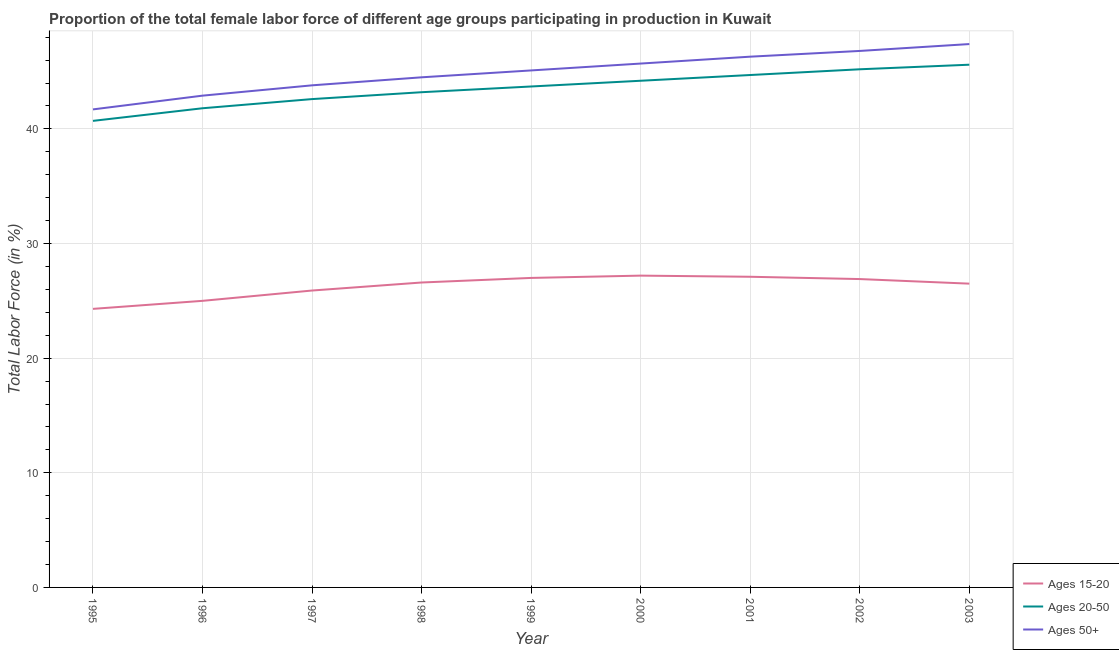How many different coloured lines are there?
Keep it short and to the point. 3. Does the line corresponding to percentage of female labor force within the age group 20-50 intersect with the line corresponding to percentage of female labor force above age 50?
Your answer should be very brief. No. What is the percentage of female labor force within the age group 20-50 in 1998?
Make the answer very short. 43.2. Across all years, what is the maximum percentage of female labor force within the age group 15-20?
Make the answer very short. 27.2. Across all years, what is the minimum percentage of female labor force within the age group 20-50?
Provide a succinct answer. 40.7. In which year was the percentage of female labor force above age 50 minimum?
Keep it short and to the point. 1995. What is the total percentage of female labor force within the age group 15-20 in the graph?
Give a very brief answer. 236.5. What is the difference between the percentage of female labor force above age 50 in 2002 and that in 2003?
Make the answer very short. -0.6. What is the difference between the percentage of female labor force above age 50 in 1997 and the percentage of female labor force within the age group 20-50 in 2001?
Your answer should be very brief. -0.9. What is the average percentage of female labor force above age 50 per year?
Provide a short and direct response. 44.91. In how many years, is the percentage of female labor force above age 50 greater than 10 %?
Offer a terse response. 9. What is the ratio of the percentage of female labor force within the age group 20-50 in 2000 to that in 2001?
Ensure brevity in your answer.  0.99. Is the percentage of female labor force within the age group 15-20 in 1998 less than that in 1999?
Keep it short and to the point. Yes. What is the difference between the highest and the second highest percentage of female labor force above age 50?
Your answer should be very brief. 0.6. What is the difference between the highest and the lowest percentage of female labor force within the age group 20-50?
Keep it short and to the point. 4.9. Is the sum of the percentage of female labor force within the age group 20-50 in 1999 and 2001 greater than the maximum percentage of female labor force within the age group 15-20 across all years?
Your answer should be compact. Yes. Is it the case that in every year, the sum of the percentage of female labor force within the age group 15-20 and percentage of female labor force within the age group 20-50 is greater than the percentage of female labor force above age 50?
Give a very brief answer. Yes. Are the values on the major ticks of Y-axis written in scientific E-notation?
Your response must be concise. No. Does the graph contain any zero values?
Your response must be concise. No. What is the title of the graph?
Provide a short and direct response. Proportion of the total female labor force of different age groups participating in production in Kuwait. Does "Non-communicable diseases" appear as one of the legend labels in the graph?
Your answer should be very brief. No. What is the Total Labor Force (in %) in Ages 15-20 in 1995?
Your answer should be compact. 24.3. What is the Total Labor Force (in %) in Ages 20-50 in 1995?
Provide a succinct answer. 40.7. What is the Total Labor Force (in %) of Ages 50+ in 1995?
Give a very brief answer. 41.7. What is the Total Labor Force (in %) of Ages 20-50 in 1996?
Your response must be concise. 41.8. What is the Total Labor Force (in %) in Ages 50+ in 1996?
Your answer should be compact. 42.9. What is the Total Labor Force (in %) of Ages 15-20 in 1997?
Give a very brief answer. 25.9. What is the Total Labor Force (in %) in Ages 20-50 in 1997?
Your answer should be compact. 42.6. What is the Total Labor Force (in %) in Ages 50+ in 1997?
Make the answer very short. 43.8. What is the Total Labor Force (in %) in Ages 15-20 in 1998?
Give a very brief answer. 26.6. What is the Total Labor Force (in %) in Ages 20-50 in 1998?
Offer a very short reply. 43.2. What is the Total Labor Force (in %) in Ages 50+ in 1998?
Your response must be concise. 44.5. What is the Total Labor Force (in %) of Ages 20-50 in 1999?
Give a very brief answer. 43.7. What is the Total Labor Force (in %) of Ages 50+ in 1999?
Provide a succinct answer. 45.1. What is the Total Labor Force (in %) in Ages 15-20 in 2000?
Offer a very short reply. 27.2. What is the Total Labor Force (in %) of Ages 20-50 in 2000?
Your answer should be compact. 44.2. What is the Total Labor Force (in %) in Ages 50+ in 2000?
Provide a short and direct response. 45.7. What is the Total Labor Force (in %) of Ages 15-20 in 2001?
Your response must be concise. 27.1. What is the Total Labor Force (in %) in Ages 20-50 in 2001?
Your response must be concise. 44.7. What is the Total Labor Force (in %) in Ages 50+ in 2001?
Your answer should be very brief. 46.3. What is the Total Labor Force (in %) of Ages 15-20 in 2002?
Offer a terse response. 26.9. What is the Total Labor Force (in %) of Ages 20-50 in 2002?
Offer a very short reply. 45.2. What is the Total Labor Force (in %) of Ages 50+ in 2002?
Your answer should be compact. 46.8. What is the Total Labor Force (in %) of Ages 20-50 in 2003?
Your answer should be compact. 45.6. What is the Total Labor Force (in %) in Ages 50+ in 2003?
Make the answer very short. 47.4. Across all years, what is the maximum Total Labor Force (in %) in Ages 15-20?
Keep it short and to the point. 27.2. Across all years, what is the maximum Total Labor Force (in %) of Ages 20-50?
Offer a terse response. 45.6. Across all years, what is the maximum Total Labor Force (in %) in Ages 50+?
Offer a terse response. 47.4. Across all years, what is the minimum Total Labor Force (in %) in Ages 15-20?
Provide a short and direct response. 24.3. Across all years, what is the minimum Total Labor Force (in %) in Ages 20-50?
Make the answer very short. 40.7. Across all years, what is the minimum Total Labor Force (in %) of Ages 50+?
Your answer should be compact. 41.7. What is the total Total Labor Force (in %) in Ages 15-20 in the graph?
Provide a succinct answer. 236.5. What is the total Total Labor Force (in %) of Ages 20-50 in the graph?
Give a very brief answer. 391.7. What is the total Total Labor Force (in %) of Ages 50+ in the graph?
Ensure brevity in your answer.  404.2. What is the difference between the Total Labor Force (in %) of Ages 50+ in 1995 and that in 1996?
Your answer should be very brief. -1.2. What is the difference between the Total Labor Force (in %) in Ages 15-20 in 1995 and that in 1998?
Your answer should be very brief. -2.3. What is the difference between the Total Labor Force (in %) of Ages 50+ in 1995 and that in 1998?
Ensure brevity in your answer.  -2.8. What is the difference between the Total Labor Force (in %) of Ages 20-50 in 1995 and that in 1999?
Provide a succinct answer. -3. What is the difference between the Total Labor Force (in %) of Ages 50+ in 1995 and that in 1999?
Ensure brevity in your answer.  -3.4. What is the difference between the Total Labor Force (in %) of Ages 15-20 in 1995 and that in 2000?
Provide a short and direct response. -2.9. What is the difference between the Total Labor Force (in %) of Ages 50+ in 1995 and that in 2001?
Your answer should be compact. -4.6. What is the difference between the Total Labor Force (in %) in Ages 15-20 in 1995 and that in 2002?
Ensure brevity in your answer.  -2.6. What is the difference between the Total Labor Force (in %) in Ages 20-50 in 1995 and that in 2002?
Offer a very short reply. -4.5. What is the difference between the Total Labor Force (in %) of Ages 50+ in 1995 and that in 2002?
Your answer should be very brief. -5.1. What is the difference between the Total Labor Force (in %) of Ages 15-20 in 1995 and that in 2003?
Your answer should be compact. -2.2. What is the difference between the Total Labor Force (in %) in Ages 15-20 in 1996 and that in 1997?
Your response must be concise. -0.9. What is the difference between the Total Labor Force (in %) in Ages 50+ in 1996 and that in 1997?
Make the answer very short. -0.9. What is the difference between the Total Labor Force (in %) in Ages 15-20 in 1996 and that in 1998?
Your response must be concise. -1.6. What is the difference between the Total Labor Force (in %) in Ages 20-50 in 1996 and that in 1998?
Your answer should be very brief. -1.4. What is the difference between the Total Labor Force (in %) of Ages 50+ in 1996 and that in 1998?
Make the answer very short. -1.6. What is the difference between the Total Labor Force (in %) of Ages 50+ in 1996 and that in 1999?
Your answer should be compact. -2.2. What is the difference between the Total Labor Force (in %) in Ages 15-20 in 1996 and that in 2000?
Make the answer very short. -2.2. What is the difference between the Total Labor Force (in %) of Ages 50+ in 1996 and that in 2000?
Your answer should be compact. -2.8. What is the difference between the Total Labor Force (in %) of Ages 20-50 in 1996 and that in 2001?
Offer a very short reply. -2.9. What is the difference between the Total Labor Force (in %) in Ages 50+ in 1996 and that in 2001?
Offer a terse response. -3.4. What is the difference between the Total Labor Force (in %) of Ages 15-20 in 1996 and that in 2002?
Give a very brief answer. -1.9. What is the difference between the Total Labor Force (in %) of Ages 15-20 in 1996 and that in 2003?
Provide a succinct answer. -1.5. What is the difference between the Total Labor Force (in %) in Ages 20-50 in 1996 and that in 2003?
Ensure brevity in your answer.  -3.8. What is the difference between the Total Labor Force (in %) in Ages 15-20 in 1997 and that in 1998?
Offer a terse response. -0.7. What is the difference between the Total Labor Force (in %) in Ages 20-50 in 1997 and that in 1999?
Make the answer very short. -1.1. What is the difference between the Total Labor Force (in %) in Ages 50+ in 1997 and that in 1999?
Give a very brief answer. -1.3. What is the difference between the Total Labor Force (in %) of Ages 20-50 in 1997 and that in 2000?
Give a very brief answer. -1.6. What is the difference between the Total Labor Force (in %) in Ages 50+ in 1997 and that in 2000?
Keep it short and to the point. -1.9. What is the difference between the Total Labor Force (in %) in Ages 50+ in 1997 and that in 2001?
Your answer should be very brief. -2.5. What is the difference between the Total Labor Force (in %) of Ages 15-20 in 1997 and that in 2002?
Keep it short and to the point. -1. What is the difference between the Total Labor Force (in %) of Ages 20-50 in 1997 and that in 2002?
Offer a very short reply. -2.6. What is the difference between the Total Labor Force (in %) of Ages 50+ in 1997 and that in 2003?
Provide a succinct answer. -3.6. What is the difference between the Total Labor Force (in %) in Ages 15-20 in 1998 and that in 1999?
Give a very brief answer. -0.4. What is the difference between the Total Labor Force (in %) in Ages 15-20 in 1998 and that in 2000?
Give a very brief answer. -0.6. What is the difference between the Total Labor Force (in %) in Ages 20-50 in 1998 and that in 2000?
Ensure brevity in your answer.  -1. What is the difference between the Total Labor Force (in %) in Ages 15-20 in 1998 and that in 2001?
Your response must be concise. -0.5. What is the difference between the Total Labor Force (in %) of Ages 50+ in 1998 and that in 2001?
Your response must be concise. -1.8. What is the difference between the Total Labor Force (in %) of Ages 20-50 in 1998 and that in 2002?
Keep it short and to the point. -2. What is the difference between the Total Labor Force (in %) of Ages 50+ in 1998 and that in 2002?
Offer a very short reply. -2.3. What is the difference between the Total Labor Force (in %) of Ages 50+ in 1999 and that in 2000?
Keep it short and to the point. -0.6. What is the difference between the Total Labor Force (in %) of Ages 15-20 in 1999 and that in 2001?
Ensure brevity in your answer.  -0.1. What is the difference between the Total Labor Force (in %) in Ages 20-50 in 1999 and that in 2001?
Make the answer very short. -1. What is the difference between the Total Labor Force (in %) of Ages 20-50 in 1999 and that in 2002?
Your response must be concise. -1.5. What is the difference between the Total Labor Force (in %) in Ages 50+ in 1999 and that in 2002?
Offer a terse response. -1.7. What is the difference between the Total Labor Force (in %) of Ages 20-50 in 1999 and that in 2003?
Offer a very short reply. -1.9. What is the difference between the Total Labor Force (in %) in Ages 15-20 in 2000 and that in 2001?
Your answer should be compact. 0.1. What is the difference between the Total Labor Force (in %) in Ages 20-50 in 2000 and that in 2001?
Give a very brief answer. -0.5. What is the difference between the Total Labor Force (in %) of Ages 50+ in 2000 and that in 2001?
Offer a very short reply. -0.6. What is the difference between the Total Labor Force (in %) of Ages 15-20 in 2000 and that in 2003?
Keep it short and to the point. 0.7. What is the difference between the Total Labor Force (in %) in Ages 50+ in 2000 and that in 2003?
Offer a very short reply. -1.7. What is the difference between the Total Labor Force (in %) in Ages 15-20 in 2001 and that in 2002?
Your answer should be very brief. 0.2. What is the difference between the Total Labor Force (in %) of Ages 20-50 in 2001 and that in 2002?
Give a very brief answer. -0.5. What is the difference between the Total Labor Force (in %) of Ages 15-20 in 2001 and that in 2003?
Your response must be concise. 0.6. What is the difference between the Total Labor Force (in %) in Ages 50+ in 2001 and that in 2003?
Provide a succinct answer. -1.1. What is the difference between the Total Labor Force (in %) of Ages 15-20 in 2002 and that in 2003?
Provide a succinct answer. 0.4. What is the difference between the Total Labor Force (in %) of Ages 20-50 in 2002 and that in 2003?
Your answer should be very brief. -0.4. What is the difference between the Total Labor Force (in %) of Ages 50+ in 2002 and that in 2003?
Offer a terse response. -0.6. What is the difference between the Total Labor Force (in %) of Ages 15-20 in 1995 and the Total Labor Force (in %) of Ages 20-50 in 1996?
Keep it short and to the point. -17.5. What is the difference between the Total Labor Force (in %) of Ages 15-20 in 1995 and the Total Labor Force (in %) of Ages 50+ in 1996?
Provide a short and direct response. -18.6. What is the difference between the Total Labor Force (in %) of Ages 20-50 in 1995 and the Total Labor Force (in %) of Ages 50+ in 1996?
Provide a succinct answer. -2.2. What is the difference between the Total Labor Force (in %) of Ages 15-20 in 1995 and the Total Labor Force (in %) of Ages 20-50 in 1997?
Provide a short and direct response. -18.3. What is the difference between the Total Labor Force (in %) in Ages 15-20 in 1995 and the Total Labor Force (in %) in Ages 50+ in 1997?
Offer a very short reply. -19.5. What is the difference between the Total Labor Force (in %) in Ages 20-50 in 1995 and the Total Labor Force (in %) in Ages 50+ in 1997?
Offer a very short reply. -3.1. What is the difference between the Total Labor Force (in %) in Ages 15-20 in 1995 and the Total Labor Force (in %) in Ages 20-50 in 1998?
Give a very brief answer. -18.9. What is the difference between the Total Labor Force (in %) in Ages 15-20 in 1995 and the Total Labor Force (in %) in Ages 50+ in 1998?
Provide a succinct answer. -20.2. What is the difference between the Total Labor Force (in %) of Ages 15-20 in 1995 and the Total Labor Force (in %) of Ages 20-50 in 1999?
Your response must be concise. -19.4. What is the difference between the Total Labor Force (in %) in Ages 15-20 in 1995 and the Total Labor Force (in %) in Ages 50+ in 1999?
Provide a succinct answer. -20.8. What is the difference between the Total Labor Force (in %) of Ages 15-20 in 1995 and the Total Labor Force (in %) of Ages 20-50 in 2000?
Make the answer very short. -19.9. What is the difference between the Total Labor Force (in %) in Ages 15-20 in 1995 and the Total Labor Force (in %) in Ages 50+ in 2000?
Give a very brief answer. -21.4. What is the difference between the Total Labor Force (in %) in Ages 20-50 in 1995 and the Total Labor Force (in %) in Ages 50+ in 2000?
Provide a short and direct response. -5. What is the difference between the Total Labor Force (in %) in Ages 15-20 in 1995 and the Total Labor Force (in %) in Ages 20-50 in 2001?
Your response must be concise. -20.4. What is the difference between the Total Labor Force (in %) in Ages 20-50 in 1995 and the Total Labor Force (in %) in Ages 50+ in 2001?
Keep it short and to the point. -5.6. What is the difference between the Total Labor Force (in %) of Ages 15-20 in 1995 and the Total Labor Force (in %) of Ages 20-50 in 2002?
Provide a succinct answer. -20.9. What is the difference between the Total Labor Force (in %) in Ages 15-20 in 1995 and the Total Labor Force (in %) in Ages 50+ in 2002?
Give a very brief answer. -22.5. What is the difference between the Total Labor Force (in %) in Ages 15-20 in 1995 and the Total Labor Force (in %) in Ages 20-50 in 2003?
Ensure brevity in your answer.  -21.3. What is the difference between the Total Labor Force (in %) in Ages 15-20 in 1995 and the Total Labor Force (in %) in Ages 50+ in 2003?
Your answer should be very brief. -23.1. What is the difference between the Total Labor Force (in %) of Ages 15-20 in 1996 and the Total Labor Force (in %) of Ages 20-50 in 1997?
Offer a very short reply. -17.6. What is the difference between the Total Labor Force (in %) in Ages 15-20 in 1996 and the Total Labor Force (in %) in Ages 50+ in 1997?
Make the answer very short. -18.8. What is the difference between the Total Labor Force (in %) in Ages 20-50 in 1996 and the Total Labor Force (in %) in Ages 50+ in 1997?
Your answer should be very brief. -2. What is the difference between the Total Labor Force (in %) of Ages 15-20 in 1996 and the Total Labor Force (in %) of Ages 20-50 in 1998?
Provide a short and direct response. -18.2. What is the difference between the Total Labor Force (in %) of Ages 15-20 in 1996 and the Total Labor Force (in %) of Ages 50+ in 1998?
Your answer should be compact. -19.5. What is the difference between the Total Labor Force (in %) of Ages 20-50 in 1996 and the Total Labor Force (in %) of Ages 50+ in 1998?
Provide a succinct answer. -2.7. What is the difference between the Total Labor Force (in %) of Ages 15-20 in 1996 and the Total Labor Force (in %) of Ages 20-50 in 1999?
Offer a very short reply. -18.7. What is the difference between the Total Labor Force (in %) of Ages 15-20 in 1996 and the Total Labor Force (in %) of Ages 50+ in 1999?
Provide a succinct answer. -20.1. What is the difference between the Total Labor Force (in %) of Ages 15-20 in 1996 and the Total Labor Force (in %) of Ages 20-50 in 2000?
Offer a terse response. -19.2. What is the difference between the Total Labor Force (in %) of Ages 15-20 in 1996 and the Total Labor Force (in %) of Ages 50+ in 2000?
Your answer should be very brief. -20.7. What is the difference between the Total Labor Force (in %) of Ages 15-20 in 1996 and the Total Labor Force (in %) of Ages 20-50 in 2001?
Your response must be concise. -19.7. What is the difference between the Total Labor Force (in %) of Ages 15-20 in 1996 and the Total Labor Force (in %) of Ages 50+ in 2001?
Provide a short and direct response. -21.3. What is the difference between the Total Labor Force (in %) in Ages 15-20 in 1996 and the Total Labor Force (in %) in Ages 20-50 in 2002?
Ensure brevity in your answer.  -20.2. What is the difference between the Total Labor Force (in %) of Ages 15-20 in 1996 and the Total Labor Force (in %) of Ages 50+ in 2002?
Your answer should be compact. -21.8. What is the difference between the Total Labor Force (in %) in Ages 15-20 in 1996 and the Total Labor Force (in %) in Ages 20-50 in 2003?
Keep it short and to the point. -20.6. What is the difference between the Total Labor Force (in %) of Ages 15-20 in 1996 and the Total Labor Force (in %) of Ages 50+ in 2003?
Your answer should be very brief. -22.4. What is the difference between the Total Labor Force (in %) of Ages 15-20 in 1997 and the Total Labor Force (in %) of Ages 20-50 in 1998?
Keep it short and to the point. -17.3. What is the difference between the Total Labor Force (in %) of Ages 15-20 in 1997 and the Total Labor Force (in %) of Ages 50+ in 1998?
Your answer should be very brief. -18.6. What is the difference between the Total Labor Force (in %) in Ages 15-20 in 1997 and the Total Labor Force (in %) in Ages 20-50 in 1999?
Your answer should be very brief. -17.8. What is the difference between the Total Labor Force (in %) in Ages 15-20 in 1997 and the Total Labor Force (in %) in Ages 50+ in 1999?
Ensure brevity in your answer.  -19.2. What is the difference between the Total Labor Force (in %) in Ages 15-20 in 1997 and the Total Labor Force (in %) in Ages 20-50 in 2000?
Provide a succinct answer. -18.3. What is the difference between the Total Labor Force (in %) of Ages 15-20 in 1997 and the Total Labor Force (in %) of Ages 50+ in 2000?
Your response must be concise. -19.8. What is the difference between the Total Labor Force (in %) in Ages 20-50 in 1997 and the Total Labor Force (in %) in Ages 50+ in 2000?
Provide a short and direct response. -3.1. What is the difference between the Total Labor Force (in %) of Ages 15-20 in 1997 and the Total Labor Force (in %) of Ages 20-50 in 2001?
Give a very brief answer. -18.8. What is the difference between the Total Labor Force (in %) in Ages 15-20 in 1997 and the Total Labor Force (in %) in Ages 50+ in 2001?
Give a very brief answer. -20.4. What is the difference between the Total Labor Force (in %) of Ages 20-50 in 1997 and the Total Labor Force (in %) of Ages 50+ in 2001?
Provide a short and direct response. -3.7. What is the difference between the Total Labor Force (in %) in Ages 15-20 in 1997 and the Total Labor Force (in %) in Ages 20-50 in 2002?
Your answer should be compact. -19.3. What is the difference between the Total Labor Force (in %) of Ages 15-20 in 1997 and the Total Labor Force (in %) of Ages 50+ in 2002?
Make the answer very short. -20.9. What is the difference between the Total Labor Force (in %) in Ages 15-20 in 1997 and the Total Labor Force (in %) in Ages 20-50 in 2003?
Your answer should be compact. -19.7. What is the difference between the Total Labor Force (in %) in Ages 15-20 in 1997 and the Total Labor Force (in %) in Ages 50+ in 2003?
Your response must be concise. -21.5. What is the difference between the Total Labor Force (in %) of Ages 20-50 in 1997 and the Total Labor Force (in %) of Ages 50+ in 2003?
Give a very brief answer. -4.8. What is the difference between the Total Labor Force (in %) in Ages 15-20 in 1998 and the Total Labor Force (in %) in Ages 20-50 in 1999?
Keep it short and to the point. -17.1. What is the difference between the Total Labor Force (in %) of Ages 15-20 in 1998 and the Total Labor Force (in %) of Ages 50+ in 1999?
Your answer should be compact. -18.5. What is the difference between the Total Labor Force (in %) in Ages 15-20 in 1998 and the Total Labor Force (in %) in Ages 20-50 in 2000?
Your answer should be very brief. -17.6. What is the difference between the Total Labor Force (in %) of Ages 15-20 in 1998 and the Total Labor Force (in %) of Ages 50+ in 2000?
Your answer should be very brief. -19.1. What is the difference between the Total Labor Force (in %) in Ages 15-20 in 1998 and the Total Labor Force (in %) in Ages 20-50 in 2001?
Offer a very short reply. -18.1. What is the difference between the Total Labor Force (in %) in Ages 15-20 in 1998 and the Total Labor Force (in %) in Ages 50+ in 2001?
Offer a very short reply. -19.7. What is the difference between the Total Labor Force (in %) in Ages 20-50 in 1998 and the Total Labor Force (in %) in Ages 50+ in 2001?
Your response must be concise. -3.1. What is the difference between the Total Labor Force (in %) in Ages 15-20 in 1998 and the Total Labor Force (in %) in Ages 20-50 in 2002?
Give a very brief answer. -18.6. What is the difference between the Total Labor Force (in %) in Ages 15-20 in 1998 and the Total Labor Force (in %) in Ages 50+ in 2002?
Make the answer very short. -20.2. What is the difference between the Total Labor Force (in %) in Ages 15-20 in 1998 and the Total Labor Force (in %) in Ages 20-50 in 2003?
Your answer should be very brief. -19. What is the difference between the Total Labor Force (in %) in Ages 15-20 in 1998 and the Total Labor Force (in %) in Ages 50+ in 2003?
Your answer should be very brief. -20.8. What is the difference between the Total Labor Force (in %) of Ages 20-50 in 1998 and the Total Labor Force (in %) of Ages 50+ in 2003?
Ensure brevity in your answer.  -4.2. What is the difference between the Total Labor Force (in %) of Ages 15-20 in 1999 and the Total Labor Force (in %) of Ages 20-50 in 2000?
Ensure brevity in your answer.  -17.2. What is the difference between the Total Labor Force (in %) in Ages 15-20 in 1999 and the Total Labor Force (in %) in Ages 50+ in 2000?
Keep it short and to the point. -18.7. What is the difference between the Total Labor Force (in %) in Ages 15-20 in 1999 and the Total Labor Force (in %) in Ages 20-50 in 2001?
Make the answer very short. -17.7. What is the difference between the Total Labor Force (in %) of Ages 15-20 in 1999 and the Total Labor Force (in %) of Ages 50+ in 2001?
Give a very brief answer. -19.3. What is the difference between the Total Labor Force (in %) in Ages 20-50 in 1999 and the Total Labor Force (in %) in Ages 50+ in 2001?
Provide a short and direct response. -2.6. What is the difference between the Total Labor Force (in %) in Ages 15-20 in 1999 and the Total Labor Force (in %) in Ages 20-50 in 2002?
Provide a succinct answer. -18.2. What is the difference between the Total Labor Force (in %) of Ages 15-20 in 1999 and the Total Labor Force (in %) of Ages 50+ in 2002?
Your answer should be compact. -19.8. What is the difference between the Total Labor Force (in %) of Ages 15-20 in 1999 and the Total Labor Force (in %) of Ages 20-50 in 2003?
Offer a very short reply. -18.6. What is the difference between the Total Labor Force (in %) of Ages 15-20 in 1999 and the Total Labor Force (in %) of Ages 50+ in 2003?
Your answer should be compact. -20.4. What is the difference between the Total Labor Force (in %) in Ages 15-20 in 2000 and the Total Labor Force (in %) in Ages 20-50 in 2001?
Give a very brief answer. -17.5. What is the difference between the Total Labor Force (in %) of Ages 15-20 in 2000 and the Total Labor Force (in %) of Ages 50+ in 2001?
Offer a very short reply. -19.1. What is the difference between the Total Labor Force (in %) in Ages 20-50 in 2000 and the Total Labor Force (in %) in Ages 50+ in 2001?
Provide a succinct answer. -2.1. What is the difference between the Total Labor Force (in %) of Ages 15-20 in 2000 and the Total Labor Force (in %) of Ages 20-50 in 2002?
Your answer should be very brief. -18. What is the difference between the Total Labor Force (in %) of Ages 15-20 in 2000 and the Total Labor Force (in %) of Ages 50+ in 2002?
Your answer should be very brief. -19.6. What is the difference between the Total Labor Force (in %) of Ages 15-20 in 2000 and the Total Labor Force (in %) of Ages 20-50 in 2003?
Keep it short and to the point. -18.4. What is the difference between the Total Labor Force (in %) in Ages 15-20 in 2000 and the Total Labor Force (in %) in Ages 50+ in 2003?
Offer a very short reply. -20.2. What is the difference between the Total Labor Force (in %) of Ages 15-20 in 2001 and the Total Labor Force (in %) of Ages 20-50 in 2002?
Keep it short and to the point. -18.1. What is the difference between the Total Labor Force (in %) of Ages 15-20 in 2001 and the Total Labor Force (in %) of Ages 50+ in 2002?
Offer a terse response. -19.7. What is the difference between the Total Labor Force (in %) of Ages 20-50 in 2001 and the Total Labor Force (in %) of Ages 50+ in 2002?
Give a very brief answer. -2.1. What is the difference between the Total Labor Force (in %) in Ages 15-20 in 2001 and the Total Labor Force (in %) in Ages 20-50 in 2003?
Offer a terse response. -18.5. What is the difference between the Total Labor Force (in %) in Ages 15-20 in 2001 and the Total Labor Force (in %) in Ages 50+ in 2003?
Make the answer very short. -20.3. What is the difference between the Total Labor Force (in %) of Ages 15-20 in 2002 and the Total Labor Force (in %) of Ages 20-50 in 2003?
Your answer should be very brief. -18.7. What is the difference between the Total Labor Force (in %) of Ages 15-20 in 2002 and the Total Labor Force (in %) of Ages 50+ in 2003?
Make the answer very short. -20.5. What is the difference between the Total Labor Force (in %) of Ages 20-50 in 2002 and the Total Labor Force (in %) of Ages 50+ in 2003?
Offer a very short reply. -2.2. What is the average Total Labor Force (in %) of Ages 15-20 per year?
Offer a very short reply. 26.28. What is the average Total Labor Force (in %) of Ages 20-50 per year?
Ensure brevity in your answer.  43.52. What is the average Total Labor Force (in %) of Ages 50+ per year?
Your answer should be very brief. 44.91. In the year 1995, what is the difference between the Total Labor Force (in %) in Ages 15-20 and Total Labor Force (in %) in Ages 20-50?
Offer a very short reply. -16.4. In the year 1995, what is the difference between the Total Labor Force (in %) in Ages 15-20 and Total Labor Force (in %) in Ages 50+?
Provide a succinct answer. -17.4. In the year 1996, what is the difference between the Total Labor Force (in %) in Ages 15-20 and Total Labor Force (in %) in Ages 20-50?
Provide a short and direct response. -16.8. In the year 1996, what is the difference between the Total Labor Force (in %) in Ages 15-20 and Total Labor Force (in %) in Ages 50+?
Provide a short and direct response. -17.9. In the year 1997, what is the difference between the Total Labor Force (in %) of Ages 15-20 and Total Labor Force (in %) of Ages 20-50?
Your answer should be very brief. -16.7. In the year 1997, what is the difference between the Total Labor Force (in %) in Ages 15-20 and Total Labor Force (in %) in Ages 50+?
Keep it short and to the point. -17.9. In the year 1998, what is the difference between the Total Labor Force (in %) of Ages 15-20 and Total Labor Force (in %) of Ages 20-50?
Your response must be concise. -16.6. In the year 1998, what is the difference between the Total Labor Force (in %) of Ages 15-20 and Total Labor Force (in %) of Ages 50+?
Your response must be concise. -17.9. In the year 1999, what is the difference between the Total Labor Force (in %) in Ages 15-20 and Total Labor Force (in %) in Ages 20-50?
Keep it short and to the point. -16.7. In the year 1999, what is the difference between the Total Labor Force (in %) of Ages 15-20 and Total Labor Force (in %) of Ages 50+?
Ensure brevity in your answer.  -18.1. In the year 1999, what is the difference between the Total Labor Force (in %) in Ages 20-50 and Total Labor Force (in %) in Ages 50+?
Make the answer very short. -1.4. In the year 2000, what is the difference between the Total Labor Force (in %) in Ages 15-20 and Total Labor Force (in %) in Ages 20-50?
Provide a succinct answer. -17. In the year 2000, what is the difference between the Total Labor Force (in %) in Ages 15-20 and Total Labor Force (in %) in Ages 50+?
Provide a short and direct response. -18.5. In the year 2000, what is the difference between the Total Labor Force (in %) in Ages 20-50 and Total Labor Force (in %) in Ages 50+?
Offer a very short reply. -1.5. In the year 2001, what is the difference between the Total Labor Force (in %) in Ages 15-20 and Total Labor Force (in %) in Ages 20-50?
Provide a short and direct response. -17.6. In the year 2001, what is the difference between the Total Labor Force (in %) in Ages 15-20 and Total Labor Force (in %) in Ages 50+?
Provide a succinct answer. -19.2. In the year 2001, what is the difference between the Total Labor Force (in %) in Ages 20-50 and Total Labor Force (in %) in Ages 50+?
Keep it short and to the point. -1.6. In the year 2002, what is the difference between the Total Labor Force (in %) in Ages 15-20 and Total Labor Force (in %) in Ages 20-50?
Keep it short and to the point. -18.3. In the year 2002, what is the difference between the Total Labor Force (in %) in Ages 15-20 and Total Labor Force (in %) in Ages 50+?
Your response must be concise. -19.9. In the year 2003, what is the difference between the Total Labor Force (in %) of Ages 15-20 and Total Labor Force (in %) of Ages 20-50?
Make the answer very short. -19.1. In the year 2003, what is the difference between the Total Labor Force (in %) of Ages 15-20 and Total Labor Force (in %) of Ages 50+?
Your response must be concise. -20.9. What is the ratio of the Total Labor Force (in %) in Ages 20-50 in 1995 to that in 1996?
Provide a succinct answer. 0.97. What is the ratio of the Total Labor Force (in %) of Ages 15-20 in 1995 to that in 1997?
Make the answer very short. 0.94. What is the ratio of the Total Labor Force (in %) in Ages 20-50 in 1995 to that in 1997?
Your response must be concise. 0.96. What is the ratio of the Total Labor Force (in %) in Ages 50+ in 1995 to that in 1997?
Ensure brevity in your answer.  0.95. What is the ratio of the Total Labor Force (in %) of Ages 15-20 in 1995 to that in 1998?
Ensure brevity in your answer.  0.91. What is the ratio of the Total Labor Force (in %) of Ages 20-50 in 1995 to that in 1998?
Your answer should be very brief. 0.94. What is the ratio of the Total Labor Force (in %) of Ages 50+ in 1995 to that in 1998?
Your answer should be compact. 0.94. What is the ratio of the Total Labor Force (in %) of Ages 20-50 in 1995 to that in 1999?
Give a very brief answer. 0.93. What is the ratio of the Total Labor Force (in %) of Ages 50+ in 1995 to that in 1999?
Ensure brevity in your answer.  0.92. What is the ratio of the Total Labor Force (in %) of Ages 15-20 in 1995 to that in 2000?
Provide a short and direct response. 0.89. What is the ratio of the Total Labor Force (in %) of Ages 20-50 in 1995 to that in 2000?
Provide a short and direct response. 0.92. What is the ratio of the Total Labor Force (in %) of Ages 50+ in 1995 to that in 2000?
Provide a short and direct response. 0.91. What is the ratio of the Total Labor Force (in %) of Ages 15-20 in 1995 to that in 2001?
Ensure brevity in your answer.  0.9. What is the ratio of the Total Labor Force (in %) in Ages 20-50 in 1995 to that in 2001?
Keep it short and to the point. 0.91. What is the ratio of the Total Labor Force (in %) of Ages 50+ in 1995 to that in 2001?
Provide a succinct answer. 0.9. What is the ratio of the Total Labor Force (in %) in Ages 15-20 in 1995 to that in 2002?
Give a very brief answer. 0.9. What is the ratio of the Total Labor Force (in %) of Ages 20-50 in 1995 to that in 2002?
Offer a very short reply. 0.9. What is the ratio of the Total Labor Force (in %) in Ages 50+ in 1995 to that in 2002?
Your answer should be very brief. 0.89. What is the ratio of the Total Labor Force (in %) in Ages 15-20 in 1995 to that in 2003?
Provide a short and direct response. 0.92. What is the ratio of the Total Labor Force (in %) of Ages 20-50 in 1995 to that in 2003?
Offer a very short reply. 0.89. What is the ratio of the Total Labor Force (in %) of Ages 50+ in 1995 to that in 2003?
Make the answer very short. 0.88. What is the ratio of the Total Labor Force (in %) in Ages 15-20 in 1996 to that in 1997?
Give a very brief answer. 0.97. What is the ratio of the Total Labor Force (in %) in Ages 20-50 in 1996 to that in 1997?
Provide a short and direct response. 0.98. What is the ratio of the Total Labor Force (in %) of Ages 50+ in 1996 to that in 1997?
Provide a short and direct response. 0.98. What is the ratio of the Total Labor Force (in %) of Ages 15-20 in 1996 to that in 1998?
Give a very brief answer. 0.94. What is the ratio of the Total Labor Force (in %) of Ages 20-50 in 1996 to that in 1998?
Offer a very short reply. 0.97. What is the ratio of the Total Labor Force (in %) in Ages 15-20 in 1996 to that in 1999?
Your answer should be very brief. 0.93. What is the ratio of the Total Labor Force (in %) of Ages 20-50 in 1996 to that in 1999?
Your answer should be compact. 0.96. What is the ratio of the Total Labor Force (in %) in Ages 50+ in 1996 to that in 1999?
Your answer should be very brief. 0.95. What is the ratio of the Total Labor Force (in %) of Ages 15-20 in 1996 to that in 2000?
Make the answer very short. 0.92. What is the ratio of the Total Labor Force (in %) of Ages 20-50 in 1996 to that in 2000?
Your answer should be compact. 0.95. What is the ratio of the Total Labor Force (in %) in Ages 50+ in 1996 to that in 2000?
Your answer should be very brief. 0.94. What is the ratio of the Total Labor Force (in %) in Ages 15-20 in 1996 to that in 2001?
Offer a terse response. 0.92. What is the ratio of the Total Labor Force (in %) of Ages 20-50 in 1996 to that in 2001?
Your answer should be very brief. 0.94. What is the ratio of the Total Labor Force (in %) of Ages 50+ in 1996 to that in 2001?
Offer a terse response. 0.93. What is the ratio of the Total Labor Force (in %) in Ages 15-20 in 1996 to that in 2002?
Your answer should be very brief. 0.93. What is the ratio of the Total Labor Force (in %) of Ages 20-50 in 1996 to that in 2002?
Keep it short and to the point. 0.92. What is the ratio of the Total Labor Force (in %) in Ages 15-20 in 1996 to that in 2003?
Your response must be concise. 0.94. What is the ratio of the Total Labor Force (in %) in Ages 20-50 in 1996 to that in 2003?
Ensure brevity in your answer.  0.92. What is the ratio of the Total Labor Force (in %) of Ages 50+ in 1996 to that in 2003?
Give a very brief answer. 0.91. What is the ratio of the Total Labor Force (in %) of Ages 15-20 in 1997 to that in 1998?
Ensure brevity in your answer.  0.97. What is the ratio of the Total Labor Force (in %) in Ages 20-50 in 1997 to that in 1998?
Give a very brief answer. 0.99. What is the ratio of the Total Labor Force (in %) in Ages 50+ in 1997 to that in 1998?
Offer a very short reply. 0.98. What is the ratio of the Total Labor Force (in %) of Ages 15-20 in 1997 to that in 1999?
Provide a succinct answer. 0.96. What is the ratio of the Total Labor Force (in %) in Ages 20-50 in 1997 to that in 1999?
Your response must be concise. 0.97. What is the ratio of the Total Labor Force (in %) of Ages 50+ in 1997 to that in 1999?
Your answer should be compact. 0.97. What is the ratio of the Total Labor Force (in %) in Ages 15-20 in 1997 to that in 2000?
Ensure brevity in your answer.  0.95. What is the ratio of the Total Labor Force (in %) of Ages 20-50 in 1997 to that in 2000?
Your answer should be compact. 0.96. What is the ratio of the Total Labor Force (in %) of Ages 50+ in 1997 to that in 2000?
Offer a very short reply. 0.96. What is the ratio of the Total Labor Force (in %) in Ages 15-20 in 1997 to that in 2001?
Your answer should be compact. 0.96. What is the ratio of the Total Labor Force (in %) of Ages 20-50 in 1997 to that in 2001?
Provide a succinct answer. 0.95. What is the ratio of the Total Labor Force (in %) of Ages 50+ in 1997 to that in 2001?
Provide a succinct answer. 0.95. What is the ratio of the Total Labor Force (in %) in Ages 15-20 in 1997 to that in 2002?
Make the answer very short. 0.96. What is the ratio of the Total Labor Force (in %) of Ages 20-50 in 1997 to that in 2002?
Offer a terse response. 0.94. What is the ratio of the Total Labor Force (in %) of Ages 50+ in 1997 to that in 2002?
Ensure brevity in your answer.  0.94. What is the ratio of the Total Labor Force (in %) in Ages 15-20 in 1997 to that in 2003?
Provide a short and direct response. 0.98. What is the ratio of the Total Labor Force (in %) of Ages 20-50 in 1997 to that in 2003?
Offer a very short reply. 0.93. What is the ratio of the Total Labor Force (in %) of Ages 50+ in 1997 to that in 2003?
Provide a succinct answer. 0.92. What is the ratio of the Total Labor Force (in %) in Ages 15-20 in 1998 to that in 1999?
Your answer should be very brief. 0.99. What is the ratio of the Total Labor Force (in %) in Ages 50+ in 1998 to that in 1999?
Provide a succinct answer. 0.99. What is the ratio of the Total Labor Force (in %) of Ages 15-20 in 1998 to that in 2000?
Make the answer very short. 0.98. What is the ratio of the Total Labor Force (in %) of Ages 20-50 in 1998 to that in 2000?
Provide a succinct answer. 0.98. What is the ratio of the Total Labor Force (in %) of Ages 50+ in 1998 to that in 2000?
Provide a succinct answer. 0.97. What is the ratio of the Total Labor Force (in %) in Ages 15-20 in 1998 to that in 2001?
Provide a short and direct response. 0.98. What is the ratio of the Total Labor Force (in %) of Ages 20-50 in 1998 to that in 2001?
Make the answer very short. 0.97. What is the ratio of the Total Labor Force (in %) of Ages 50+ in 1998 to that in 2001?
Your response must be concise. 0.96. What is the ratio of the Total Labor Force (in %) of Ages 15-20 in 1998 to that in 2002?
Offer a terse response. 0.99. What is the ratio of the Total Labor Force (in %) in Ages 20-50 in 1998 to that in 2002?
Make the answer very short. 0.96. What is the ratio of the Total Labor Force (in %) in Ages 50+ in 1998 to that in 2002?
Give a very brief answer. 0.95. What is the ratio of the Total Labor Force (in %) in Ages 15-20 in 1998 to that in 2003?
Provide a succinct answer. 1. What is the ratio of the Total Labor Force (in %) of Ages 20-50 in 1998 to that in 2003?
Ensure brevity in your answer.  0.95. What is the ratio of the Total Labor Force (in %) of Ages 50+ in 1998 to that in 2003?
Provide a short and direct response. 0.94. What is the ratio of the Total Labor Force (in %) of Ages 15-20 in 1999 to that in 2000?
Give a very brief answer. 0.99. What is the ratio of the Total Labor Force (in %) in Ages 20-50 in 1999 to that in 2000?
Ensure brevity in your answer.  0.99. What is the ratio of the Total Labor Force (in %) in Ages 50+ in 1999 to that in 2000?
Ensure brevity in your answer.  0.99. What is the ratio of the Total Labor Force (in %) of Ages 20-50 in 1999 to that in 2001?
Provide a succinct answer. 0.98. What is the ratio of the Total Labor Force (in %) in Ages 50+ in 1999 to that in 2001?
Offer a very short reply. 0.97. What is the ratio of the Total Labor Force (in %) of Ages 20-50 in 1999 to that in 2002?
Offer a very short reply. 0.97. What is the ratio of the Total Labor Force (in %) in Ages 50+ in 1999 to that in 2002?
Make the answer very short. 0.96. What is the ratio of the Total Labor Force (in %) of Ages 15-20 in 1999 to that in 2003?
Offer a very short reply. 1.02. What is the ratio of the Total Labor Force (in %) of Ages 50+ in 1999 to that in 2003?
Your response must be concise. 0.95. What is the ratio of the Total Labor Force (in %) of Ages 15-20 in 2000 to that in 2001?
Keep it short and to the point. 1. What is the ratio of the Total Labor Force (in %) of Ages 20-50 in 2000 to that in 2001?
Provide a succinct answer. 0.99. What is the ratio of the Total Labor Force (in %) in Ages 50+ in 2000 to that in 2001?
Ensure brevity in your answer.  0.99. What is the ratio of the Total Labor Force (in %) in Ages 15-20 in 2000 to that in 2002?
Make the answer very short. 1.01. What is the ratio of the Total Labor Force (in %) of Ages 20-50 in 2000 to that in 2002?
Keep it short and to the point. 0.98. What is the ratio of the Total Labor Force (in %) of Ages 50+ in 2000 to that in 2002?
Keep it short and to the point. 0.98. What is the ratio of the Total Labor Force (in %) of Ages 15-20 in 2000 to that in 2003?
Your answer should be compact. 1.03. What is the ratio of the Total Labor Force (in %) in Ages 20-50 in 2000 to that in 2003?
Your response must be concise. 0.97. What is the ratio of the Total Labor Force (in %) of Ages 50+ in 2000 to that in 2003?
Ensure brevity in your answer.  0.96. What is the ratio of the Total Labor Force (in %) of Ages 15-20 in 2001 to that in 2002?
Give a very brief answer. 1.01. What is the ratio of the Total Labor Force (in %) in Ages 20-50 in 2001 to that in 2002?
Provide a short and direct response. 0.99. What is the ratio of the Total Labor Force (in %) of Ages 50+ in 2001 to that in 2002?
Make the answer very short. 0.99. What is the ratio of the Total Labor Force (in %) in Ages 15-20 in 2001 to that in 2003?
Provide a short and direct response. 1.02. What is the ratio of the Total Labor Force (in %) of Ages 20-50 in 2001 to that in 2003?
Make the answer very short. 0.98. What is the ratio of the Total Labor Force (in %) in Ages 50+ in 2001 to that in 2003?
Provide a short and direct response. 0.98. What is the ratio of the Total Labor Force (in %) in Ages 15-20 in 2002 to that in 2003?
Provide a succinct answer. 1.02. What is the ratio of the Total Labor Force (in %) in Ages 20-50 in 2002 to that in 2003?
Keep it short and to the point. 0.99. What is the ratio of the Total Labor Force (in %) in Ages 50+ in 2002 to that in 2003?
Your answer should be very brief. 0.99. What is the difference between the highest and the second highest Total Labor Force (in %) of Ages 20-50?
Your response must be concise. 0.4. What is the difference between the highest and the lowest Total Labor Force (in %) of Ages 50+?
Provide a short and direct response. 5.7. 